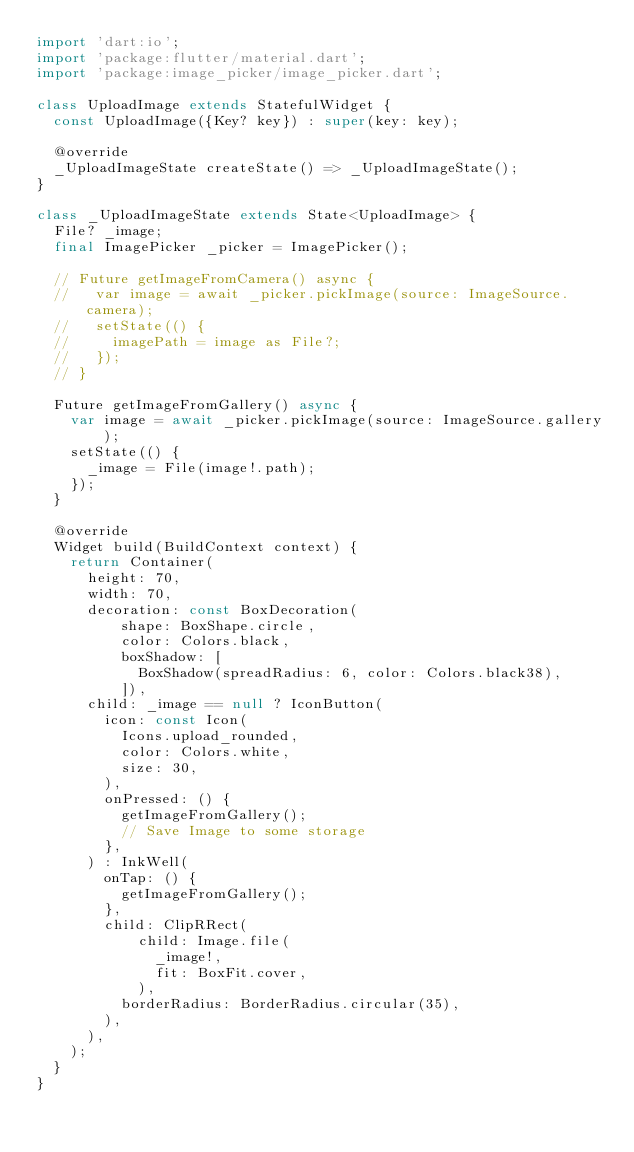Convert code to text. <code><loc_0><loc_0><loc_500><loc_500><_Dart_>import 'dart:io';
import 'package:flutter/material.dart';
import 'package:image_picker/image_picker.dart';

class UploadImage extends StatefulWidget {
  const UploadImage({Key? key}) : super(key: key);

  @override
  _UploadImageState createState() => _UploadImageState();
}

class _UploadImageState extends State<UploadImage> {
  File? _image;
  final ImagePicker _picker = ImagePicker();

  // Future getImageFromCamera() async {
  //   var image = await _picker.pickImage(source: ImageSource.camera);
  //   setState(() {
  //     imagePath = image as File?;
  //   });
  // }

  Future getImageFromGallery() async {
    var image = await _picker.pickImage(source: ImageSource.gallery);
    setState(() {
      _image = File(image!.path);
    });
  }

  @override
  Widget build(BuildContext context) {
    return Container(
      height: 70,
      width: 70,
      decoration: const BoxDecoration(
          shape: BoxShape.circle,
          color: Colors.black,
          boxShadow: [
            BoxShadow(spreadRadius: 6, color: Colors.black38),
          ]),
      child: _image == null ? IconButton(
        icon: const Icon(
          Icons.upload_rounded,
          color: Colors.white,
          size: 30,
        ),
        onPressed: () {
          getImageFromGallery();
          // Save Image to some storage
        },
      ) : InkWell(
        onTap: () {
          getImageFromGallery();
        },
        child: ClipRRect(
            child: Image.file(
              _image!,
              fit: BoxFit.cover,
            ),
          borderRadius: BorderRadius.circular(35),
        ),
      ),
    );
  }
}
</code> 